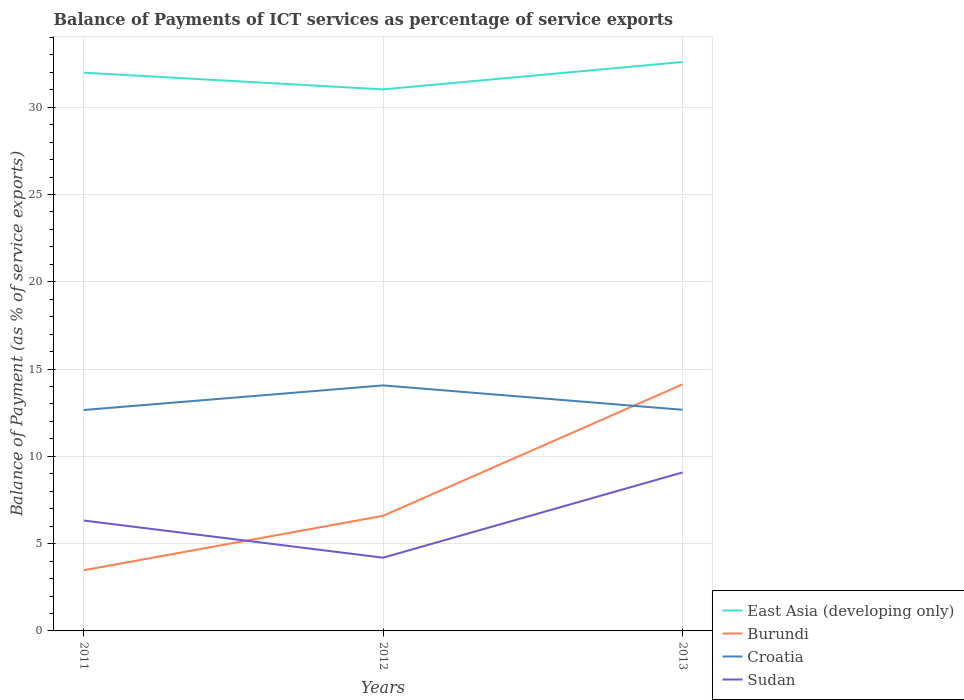How many different coloured lines are there?
Provide a short and direct response. 4. Across all years, what is the maximum balance of payments of ICT services in Burundi?
Your answer should be compact. 3.48. What is the total balance of payments of ICT services in Sudan in the graph?
Your answer should be compact. -4.88. What is the difference between the highest and the second highest balance of payments of ICT services in Croatia?
Your answer should be compact. 1.41. Is the balance of payments of ICT services in Burundi strictly greater than the balance of payments of ICT services in Sudan over the years?
Offer a very short reply. No. How many lines are there?
Your response must be concise. 4. How many years are there in the graph?
Provide a succinct answer. 3. What is the difference between two consecutive major ticks on the Y-axis?
Your response must be concise. 5. Are the values on the major ticks of Y-axis written in scientific E-notation?
Provide a succinct answer. No. Does the graph contain grids?
Provide a succinct answer. Yes. How many legend labels are there?
Your response must be concise. 4. What is the title of the graph?
Provide a short and direct response. Balance of Payments of ICT services as percentage of service exports. Does "Algeria" appear as one of the legend labels in the graph?
Ensure brevity in your answer.  No. What is the label or title of the Y-axis?
Ensure brevity in your answer.  Balance of Payment (as % of service exports). What is the Balance of Payment (as % of service exports) of East Asia (developing only) in 2011?
Keep it short and to the point. 31.98. What is the Balance of Payment (as % of service exports) in Burundi in 2011?
Your answer should be compact. 3.48. What is the Balance of Payment (as % of service exports) in Croatia in 2011?
Keep it short and to the point. 12.66. What is the Balance of Payment (as % of service exports) in Sudan in 2011?
Keep it short and to the point. 6.32. What is the Balance of Payment (as % of service exports) in East Asia (developing only) in 2012?
Give a very brief answer. 31.02. What is the Balance of Payment (as % of service exports) of Burundi in 2012?
Offer a very short reply. 6.59. What is the Balance of Payment (as % of service exports) in Croatia in 2012?
Provide a succinct answer. 14.06. What is the Balance of Payment (as % of service exports) of Sudan in 2012?
Offer a terse response. 4.2. What is the Balance of Payment (as % of service exports) in East Asia (developing only) in 2013?
Provide a succinct answer. 32.59. What is the Balance of Payment (as % of service exports) of Burundi in 2013?
Your answer should be very brief. 14.13. What is the Balance of Payment (as % of service exports) in Croatia in 2013?
Offer a very short reply. 12.67. What is the Balance of Payment (as % of service exports) of Sudan in 2013?
Your answer should be very brief. 9.08. Across all years, what is the maximum Balance of Payment (as % of service exports) in East Asia (developing only)?
Keep it short and to the point. 32.59. Across all years, what is the maximum Balance of Payment (as % of service exports) of Burundi?
Keep it short and to the point. 14.13. Across all years, what is the maximum Balance of Payment (as % of service exports) in Croatia?
Ensure brevity in your answer.  14.06. Across all years, what is the maximum Balance of Payment (as % of service exports) of Sudan?
Your response must be concise. 9.08. Across all years, what is the minimum Balance of Payment (as % of service exports) of East Asia (developing only)?
Keep it short and to the point. 31.02. Across all years, what is the minimum Balance of Payment (as % of service exports) of Burundi?
Your response must be concise. 3.48. Across all years, what is the minimum Balance of Payment (as % of service exports) of Croatia?
Your response must be concise. 12.66. Across all years, what is the minimum Balance of Payment (as % of service exports) of Sudan?
Give a very brief answer. 4.2. What is the total Balance of Payment (as % of service exports) in East Asia (developing only) in the graph?
Ensure brevity in your answer.  95.59. What is the total Balance of Payment (as % of service exports) of Burundi in the graph?
Give a very brief answer. 24.2. What is the total Balance of Payment (as % of service exports) of Croatia in the graph?
Your answer should be very brief. 39.39. What is the total Balance of Payment (as % of service exports) of Sudan in the graph?
Give a very brief answer. 19.6. What is the difference between the Balance of Payment (as % of service exports) in East Asia (developing only) in 2011 and that in 2012?
Your response must be concise. 0.96. What is the difference between the Balance of Payment (as % of service exports) in Burundi in 2011 and that in 2012?
Provide a succinct answer. -3.12. What is the difference between the Balance of Payment (as % of service exports) in Croatia in 2011 and that in 2012?
Offer a terse response. -1.41. What is the difference between the Balance of Payment (as % of service exports) in Sudan in 2011 and that in 2012?
Your response must be concise. 2.13. What is the difference between the Balance of Payment (as % of service exports) in East Asia (developing only) in 2011 and that in 2013?
Ensure brevity in your answer.  -0.61. What is the difference between the Balance of Payment (as % of service exports) of Burundi in 2011 and that in 2013?
Your answer should be compact. -10.65. What is the difference between the Balance of Payment (as % of service exports) of Croatia in 2011 and that in 2013?
Your response must be concise. -0.01. What is the difference between the Balance of Payment (as % of service exports) of Sudan in 2011 and that in 2013?
Provide a short and direct response. -2.76. What is the difference between the Balance of Payment (as % of service exports) in East Asia (developing only) in 2012 and that in 2013?
Offer a terse response. -1.57. What is the difference between the Balance of Payment (as % of service exports) in Burundi in 2012 and that in 2013?
Give a very brief answer. -7.53. What is the difference between the Balance of Payment (as % of service exports) in Croatia in 2012 and that in 2013?
Offer a terse response. 1.4. What is the difference between the Balance of Payment (as % of service exports) of Sudan in 2012 and that in 2013?
Make the answer very short. -4.88. What is the difference between the Balance of Payment (as % of service exports) of East Asia (developing only) in 2011 and the Balance of Payment (as % of service exports) of Burundi in 2012?
Provide a succinct answer. 25.38. What is the difference between the Balance of Payment (as % of service exports) of East Asia (developing only) in 2011 and the Balance of Payment (as % of service exports) of Croatia in 2012?
Provide a short and direct response. 17.91. What is the difference between the Balance of Payment (as % of service exports) in East Asia (developing only) in 2011 and the Balance of Payment (as % of service exports) in Sudan in 2012?
Make the answer very short. 27.78. What is the difference between the Balance of Payment (as % of service exports) of Burundi in 2011 and the Balance of Payment (as % of service exports) of Croatia in 2012?
Your answer should be very brief. -10.59. What is the difference between the Balance of Payment (as % of service exports) of Burundi in 2011 and the Balance of Payment (as % of service exports) of Sudan in 2012?
Offer a very short reply. -0.72. What is the difference between the Balance of Payment (as % of service exports) of Croatia in 2011 and the Balance of Payment (as % of service exports) of Sudan in 2012?
Offer a terse response. 8.46. What is the difference between the Balance of Payment (as % of service exports) of East Asia (developing only) in 2011 and the Balance of Payment (as % of service exports) of Burundi in 2013?
Offer a terse response. 17.85. What is the difference between the Balance of Payment (as % of service exports) in East Asia (developing only) in 2011 and the Balance of Payment (as % of service exports) in Croatia in 2013?
Provide a succinct answer. 19.31. What is the difference between the Balance of Payment (as % of service exports) of East Asia (developing only) in 2011 and the Balance of Payment (as % of service exports) of Sudan in 2013?
Provide a short and direct response. 22.9. What is the difference between the Balance of Payment (as % of service exports) in Burundi in 2011 and the Balance of Payment (as % of service exports) in Croatia in 2013?
Ensure brevity in your answer.  -9.19. What is the difference between the Balance of Payment (as % of service exports) in Burundi in 2011 and the Balance of Payment (as % of service exports) in Sudan in 2013?
Offer a terse response. -5.6. What is the difference between the Balance of Payment (as % of service exports) in Croatia in 2011 and the Balance of Payment (as % of service exports) in Sudan in 2013?
Your response must be concise. 3.58. What is the difference between the Balance of Payment (as % of service exports) in East Asia (developing only) in 2012 and the Balance of Payment (as % of service exports) in Burundi in 2013?
Give a very brief answer. 16.9. What is the difference between the Balance of Payment (as % of service exports) in East Asia (developing only) in 2012 and the Balance of Payment (as % of service exports) in Croatia in 2013?
Provide a short and direct response. 18.35. What is the difference between the Balance of Payment (as % of service exports) in East Asia (developing only) in 2012 and the Balance of Payment (as % of service exports) in Sudan in 2013?
Your response must be concise. 21.94. What is the difference between the Balance of Payment (as % of service exports) of Burundi in 2012 and the Balance of Payment (as % of service exports) of Croatia in 2013?
Your response must be concise. -6.07. What is the difference between the Balance of Payment (as % of service exports) in Burundi in 2012 and the Balance of Payment (as % of service exports) in Sudan in 2013?
Keep it short and to the point. -2.49. What is the difference between the Balance of Payment (as % of service exports) in Croatia in 2012 and the Balance of Payment (as % of service exports) in Sudan in 2013?
Your answer should be very brief. 4.98. What is the average Balance of Payment (as % of service exports) of East Asia (developing only) per year?
Your answer should be very brief. 31.86. What is the average Balance of Payment (as % of service exports) in Burundi per year?
Offer a terse response. 8.07. What is the average Balance of Payment (as % of service exports) of Croatia per year?
Provide a succinct answer. 13.13. What is the average Balance of Payment (as % of service exports) of Sudan per year?
Ensure brevity in your answer.  6.53. In the year 2011, what is the difference between the Balance of Payment (as % of service exports) of East Asia (developing only) and Balance of Payment (as % of service exports) of Burundi?
Give a very brief answer. 28.5. In the year 2011, what is the difference between the Balance of Payment (as % of service exports) of East Asia (developing only) and Balance of Payment (as % of service exports) of Croatia?
Provide a short and direct response. 19.32. In the year 2011, what is the difference between the Balance of Payment (as % of service exports) in East Asia (developing only) and Balance of Payment (as % of service exports) in Sudan?
Make the answer very short. 25.65. In the year 2011, what is the difference between the Balance of Payment (as % of service exports) in Burundi and Balance of Payment (as % of service exports) in Croatia?
Give a very brief answer. -9.18. In the year 2011, what is the difference between the Balance of Payment (as % of service exports) in Burundi and Balance of Payment (as % of service exports) in Sudan?
Give a very brief answer. -2.85. In the year 2011, what is the difference between the Balance of Payment (as % of service exports) of Croatia and Balance of Payment (as % of service exports) of Sudan?
Your answer should be very brief. 6.33. In the year 2012, what is the difference between the Balance of Payment (as % of service exports) in East Asia (developing only) and Balance of Payment (as % of service exports) in Burundi?
Offer a very short reply. 24.43. In the year 2012, what is the difference between the Balance of Payment (as % of service exports) in East Asia (developing only) and Balance of Payment (as % of service exports) in Croatia?
Provide a succinct answer. 16.96. In the year 2012, what is the difference between the Balance of Payment (as % of service exports) of East Asia (developing only) and Balance of Payment (as % of service exports) of Sudan?
Make the answer very short. 26.83. In the year 2012, what is the difference between the Balance of Payment (as % of service exports) in Burundi and Balance of Payment (as % of service exports) in Croatia?
Your answer should be compact. -7.47. In the year 2012, what is the difference between the Balance of Payment (as % of service exports) of Burundi and Balance of Payment (as % of service exports) of Sudan?
Provide a succinct answer. 2.4. In the year 2012, what is the difference between the Balance of Payment (as % of service exports) in Croatia and Balance of Payment (as % of service exports) in Sudan?
Keep it short and to the point. 9.87. In the year 2013, what is the difference between the Balance of Payment (as % of service exports) in East Asia (developing only) and Balance of Payment (as % of service exports) in Burundi?
Ensure brevity in your answer.  18.46. In the year 2013, what is the difference between the Balance of Payment (as % of service exports) of East Asia (developing only) and Balance of Payment (as % of service exports) of Croatia?
Your response must be concise. 19.92. In the year 2013, what is the difference between the Balance of Payment (as % of service exports) of East Asia (developing only) and Balance of Payment (as % of service exports) of Sudan?
Make the answer very short. 23.51. In the year 2013, what is the difference between the Balance of Payment (as % of service exports) of Burundi and Balance of Payment (as % of service exports) of Croatia?
Your response must be concise. 1.46. In the year 2013, what is the difference between the Balance of Payment (as % of service exports) of Burundi and Balance of Payment (as % of service exports) of Sudan?
Offer a terse response. 5.05. In the year 2013, what is the difference between the Balance of Payment (as % of service exports) in Croatia and Balance of Payment (as % of service exports) in Sudan?
Give a very brief answer. 3.59. What is the ratio of the Balance of Payment (as % of service exports) in East Asia (developing only) in 2011 to that in 2012?
Keep it short and to the point. 1.03. What is the ratio of the Balance of Payment (as % of service exports) in Burundi in 2011 to that in 2012?
Your response must be concise. 0.53. What is the ratio of the Balance of Payment (as % of service exports) of Croatia in 2011 to that in 2012?
Ensure brevity in your answer.  0.9. What is the ratio of the Balance of Payment (as % of service exports) of Sudan in 2011 to that in 2012?
Your answer should be compact. 1.51. What is the ratio of the Balance of Payment (as % of service exports) of East Asia (developing only) in 2011 to that in 2013?
Make the answer very short. 0.98. What is the ratio of the Balance of Payment (as % of service exports) of Burundi in 2011 to that in 2013?
Offer a terse response. 0.25. What is the ratio of the Balance of Payment (as % of service exports) of Sudan in 2011 to that in 2013?
Your response must be concise. 0.7. What is the ratio of the Balance of Payment (as % of service exports) in East Asia (developing only) in 2012 to that in 2013?
Keep it short and to the point. 0.95. What is the ratio of the Balance of Payment (as % of service exports) of Burundi in 2012 to that in 2013?
Ensure brevity in your answer.  0.47. What is the ratio of the Balance of Payment (as % of service exports) of Croatia in 2012 to that in 2013?
Your answer should be very brief. 1.11. What is the ratio of the Balance of Payment (as % of service exports) of Sudan in 2012 to that in 2013?
Keep it short and to the point. 0.46. What is the difference between the highest and the second highest Balance of Payment (as % of service exports) in East Asia (developing only)?
Your answer should be very brief. 0.61. What is the difference between the highest and the second highest Balance of Payment (as % of service exports) of Burundi?
Offer a terse response. 7.53. What is the difference between the highest and the second highest Balance of Payment (as % of service exports) of Croatia?
Offer a very short reply. 1.4. What is the difference between the highest and the second highest Balance of Payment (as % of service exports) of Sudan?
Offer a very short reply. 2.76. What is the difference between the highest and the lowest Balance of Payment (as % of service exports) in East Asia (developing only)?
Make the answer very short. 1.57. What is the difference between the highest and the lowest Balance of Payment (as % of service exports) in Burundi?
Make the answer very short. 10.65. What is the difference between the highest and the lowest Balance of Payment (as % of service exports) in Croatia?
Your answer should be compact. 1.41. What is the difference between the highest and the lowest Balance of Payment (as % of service exports) in Sudan?
Make the answer very short. 4.88. 